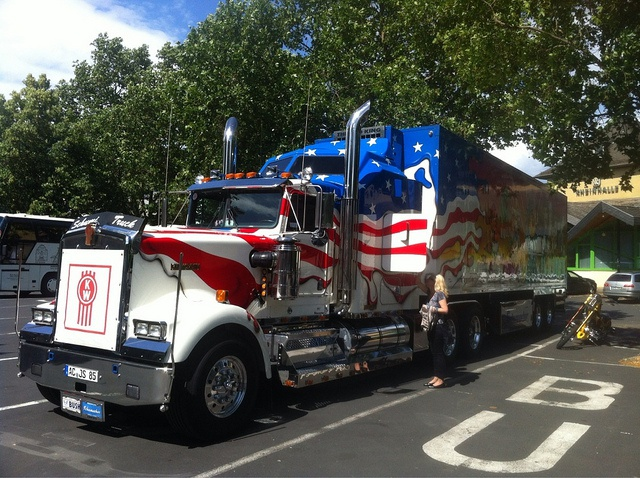Describe the objects in this image and their specific colors. I can see truck in white, black, gray, and maroon tones, bus in white, black, gray, and darkblue tones, people in white, black, gray, maroon, and tan tones, motorcycle in white, black, and gray tones, and car in white, gray, black, darkgray, and lightgray tones in this image. 